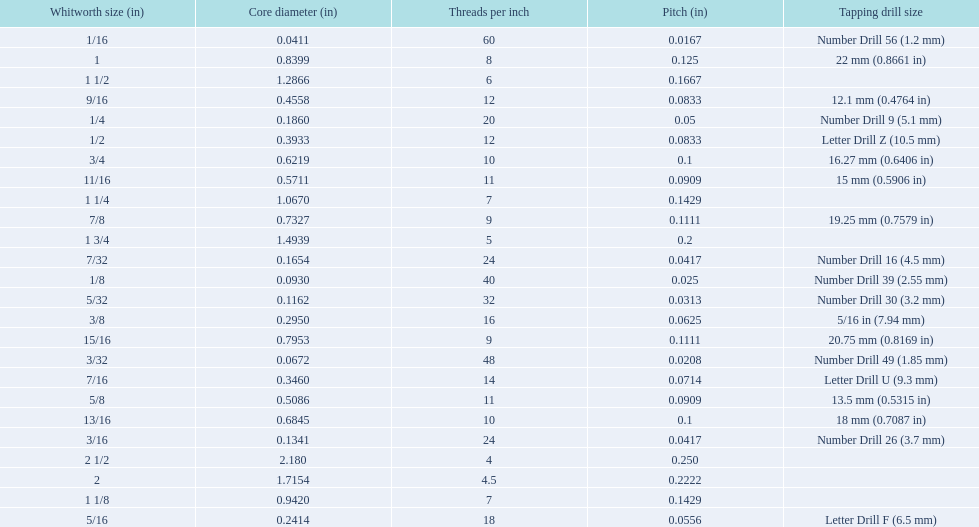What are all of the whitworth sizes in the british standard whitworth? 1/16, 3/32, 1/8, 5/32, 3/16, 7/32, 1/4, 5/16, 3/8, 7/16, 1/2, 9/16, 5/8, 11/16, 3/4, 13/16, 7/8, 15/16, 1, 1 1/8, 1 1/4, 1 1/2, 1 3/4, 2, 2 1/2. Which of these sizes uses a tapping drill size of 26? 3/16. 